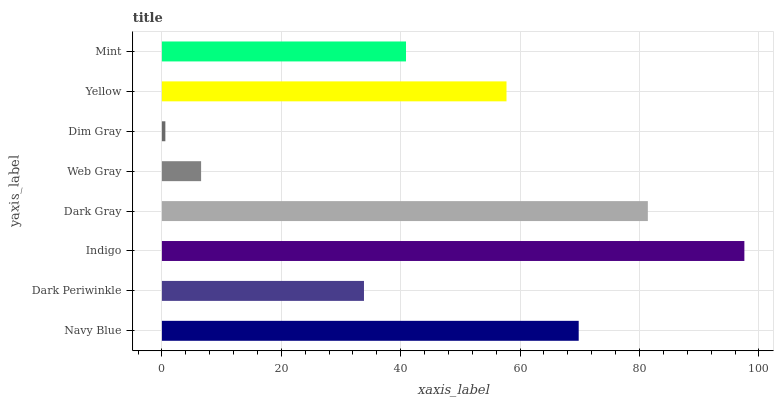Is Dim Gray the minimum?
Answer yes or no. Yes. Is Indigo the maximum?
Answer yes or no. Yes. Is Dark Periwinkle the minimum?
Answer yes or no. No. Is Dark Periwinkle the maximum?
Answer yes or no. No. Is Navy Blue greater than Dark Periwinkle?
Answer yes or no. Yes. Is Dark Periwinkle less than Navy Blue?
Answer yes or no. Yes. Is Dark Periwinkle greater than Navy Blue?
Answer yes or no. No. Is Navy Blue less than Dark Periwinkle?
Answer yes or no. No. Is Yellow the high median?
Answer yes or no. Yes. Is Mint the low median?
Answer yes or no. Yes. Is Dark Gray the high median?
Answer yes or no. No. Is Web Gray the low median?
Answer yes or no. No. 